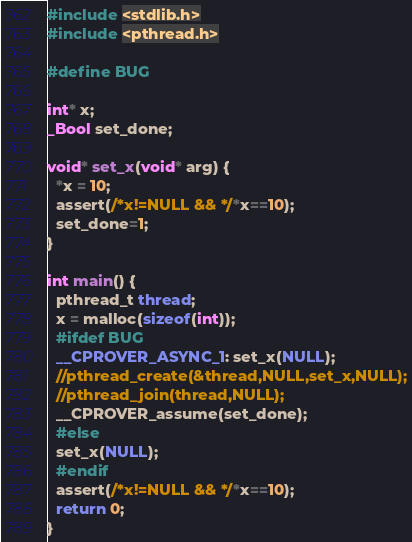<code> <loc_0><loc_0><loc_500><loc_500><_C_>#include <stdlib.h>
#include <pthread.h>

#define BUG

int* x;
_Bool set_done;

void* set_x(void* arg) {
  *x = 10;
  assert(/*x!=NULL && */*x==10);
  set_done=1;
}

int main() {
  pthread_t thread;
  x = malloc(sizeof(int));
  #ifdef BUG
  __CPROVER_ASYNC_1: set_x(NULL);
  //pthread_create(&thread,NULL,set_x,NULL);
  //pthread_join(thread,NULL);
  __CPROVER_assume(set_done);
  #else
  set_x(NULL);
  #endif
  assert(/*x!=NULL && */*x==10);
  return 0;
}
</code> 